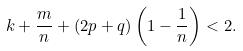<formula> <loc_0><loc_0><loc_500><loc_500>k + \frac { m } { n } + ( 2 p + q ) \left ( 1 - \frac { 1 } { n } \right ) < 2 .</formula> 